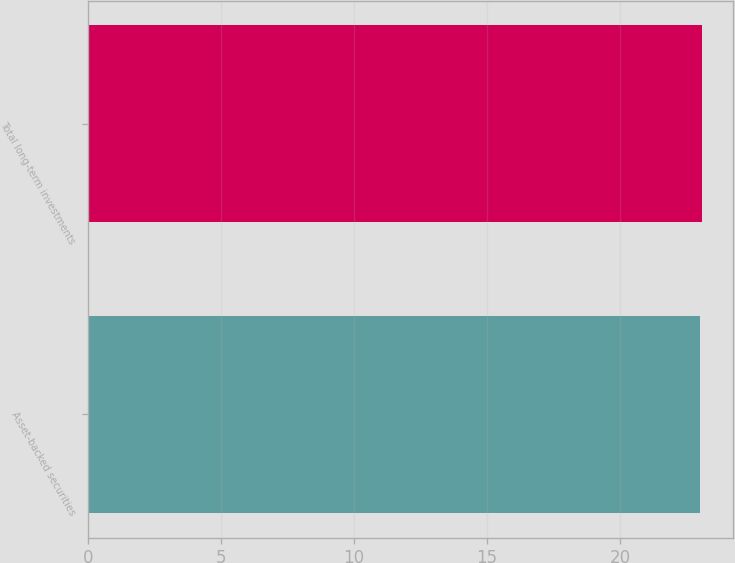<chart> <loc_0><loc_0><loc_500><loc_500><bar_chart><fcel>Asset-backed securities<fcel>Total long-term investments<nl><fcel>23<fcel>23.1<nl></chart> 